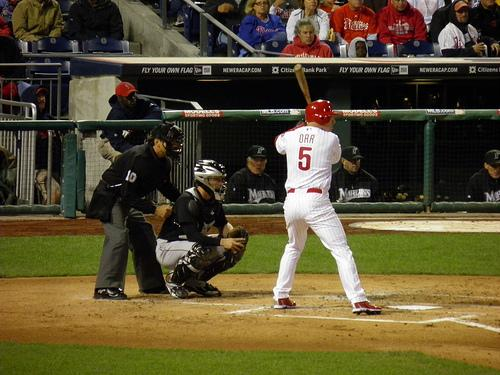What seems to be the action happening between the batter and the catcher? The batter is swinging the bat to hit the ball, and the catcher is squatting down to catch the pitch. What is the main interaction happening between the three primary characters in the image? The batter is about to swing at the incoming pitch while the catcher and umpire wait in anticipation for the ball. Describe the scene in the image concerning the audience and their location. Fans watching baseball game from terraces are seated behind a green railing and a metal fence. What is the color of the jersey and the number on the batter's back? The jersey is red and white with the number 5 on the back. What is the sentiment of the image? Excitement and anticipation, as the baseball player is about to swing at the pitch to hit the ball. Count how many baseball players are wearing red and white uniforms, and how many are wearing black and grey uniforms. One player is wearing a red and white uniform, and three players are wearing black and grey uniforms. Which elements in the image indicate that the players are professional? Uniforms with numbers, catcher's protective gear, umpire's uniform, and the presence of ad banners on the dugout roof. Identify the main objects and actions found in the image. Baseball player swinging bat, catcher awaiting pitch, umpire observing, fans watching the game, players in dugout, red helmet and shoes, advertisements on dugout roof. How many people can be seen in the image wearing red hats or helmets? Three people: the batter, a player in the dugout, and a man with a blue sweater. List all colors present in the baseball player's uniform, helmet, belt, and shoes. Red, white, gray, and black. Spot the seagull flying above the field, and take note of the baseball in its beak, which it probably stole from a near-miss hit. No, it's not mentioned in the image. Do you perceive the billboard with the advertisement for a new pizza restaurant beside the audience seating area? Pay attention to the cheesy pizza with mushrooms and bacon. Can you find the person with a large blue umbrella in the top left corner of the image? This umbrella is quite unique, as it has yellow polka dots on it. Do you see the large pink ice cream cone that a kid in the first row of the audience is holding up? This ice cream cone has three different flavoured scoops on top of each other. 